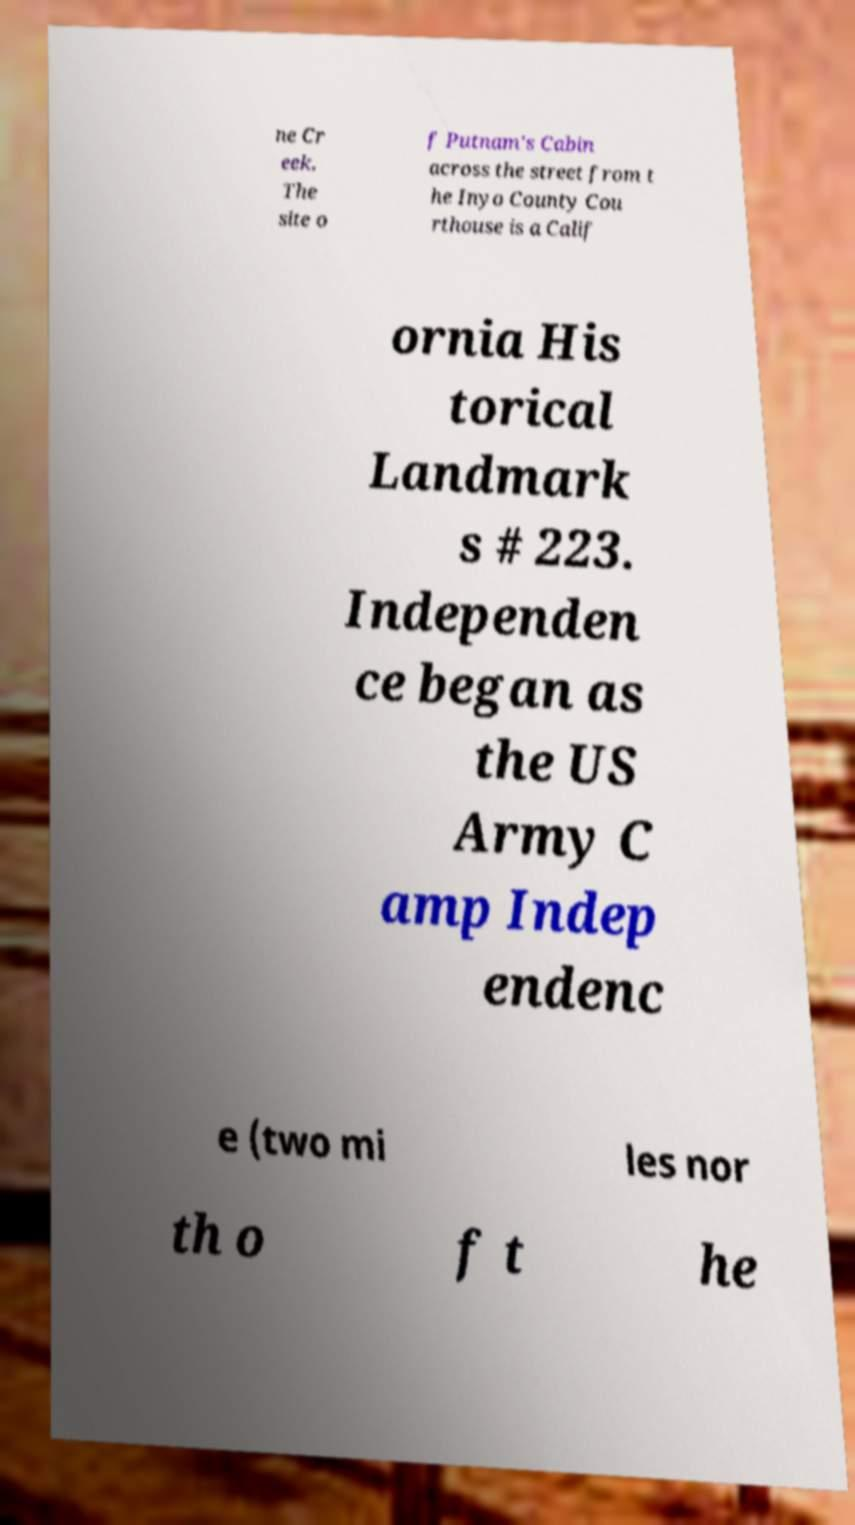Please identify and transcribe the text found in this image. ne Cr eek. The site o f Putnam's Cabin across the street from t he Inyo County Cou rthouse is a Calif ornia His torical Landmark s # 223. Independen ce began as the US Army C amp Indep endenc e (two mi les nor th o f t he 